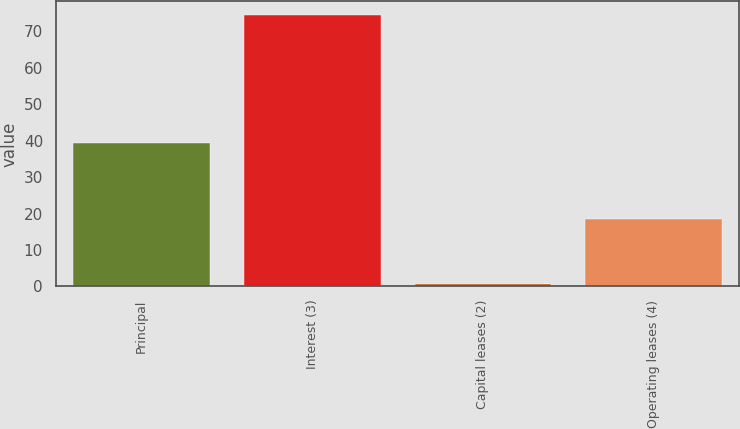Convert chart. <chart><loc_0><loc_0><loc_500><loc_500><bar_chart><fcel>Principal<fcel>Interest (3)<fcel>Capital leases (2)<fcel>Operating leases (4)<nl><fcel>39.4<fcel>74.5<fcel>0.7<fcel>18.5<nl></chart> 